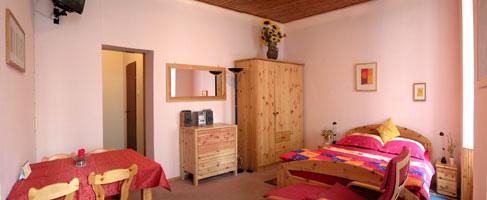What room is this?
Quick response, please. Bedroom. What type of wood is the furniture made of?
Keep it brief. Pine. Is the bed made?
Be succinct. Yes. 